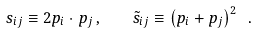Convert formula to latex. <formula><loc_0><loc_0><loc_500><loc_500>s _ { i j } \equiv 2 p _ { i } \cdot p _ { j } \, , \quad \tilde { s } _ { i j } \equiv \left ( p _ { i } + p _ { j } \right ) ^ { 2 } \ .</formula> 